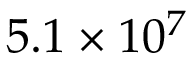Convert formula to latex. <formula><loc_0><loc_0><loc_500><loc_500>5 . 1 \times 1 0 ^ { 7 }</formula> 